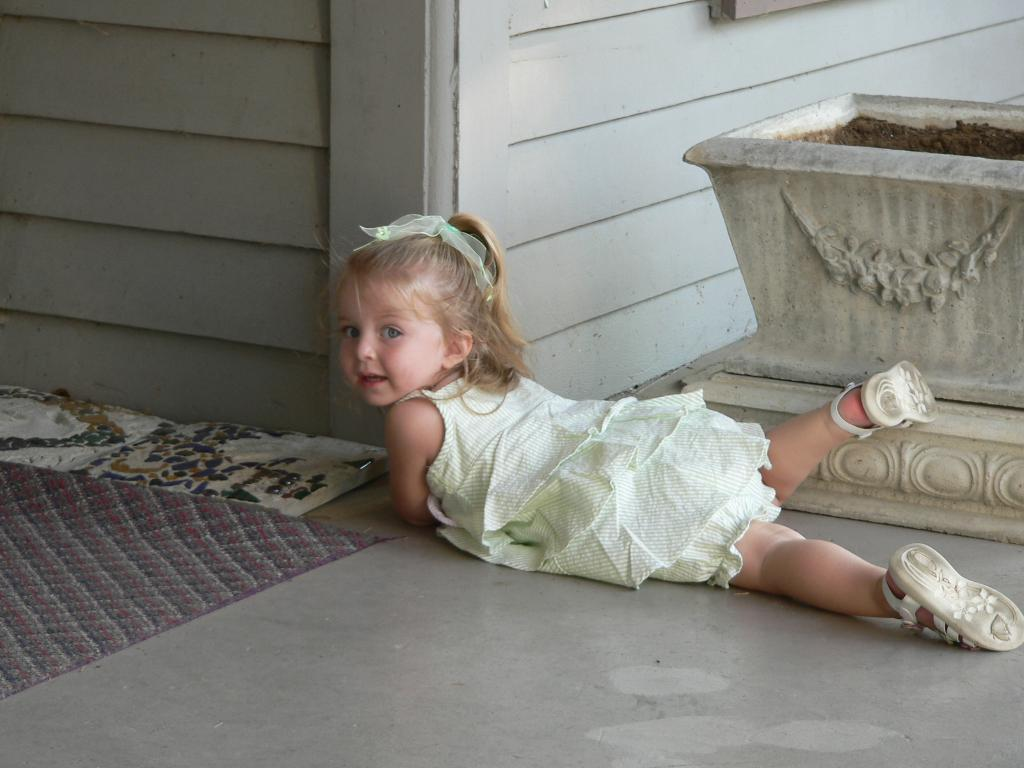What is the girl in the image doing? The girl is lying on the floor in the image. What can be seen in the background of the image? There is a container filled with sand and a building visible in the background. What type of flooring is present in the background? There is a carpet on the ground in the background. What type of bread is being used to process the salt in the image? There is no bread or salt present in the image, and therefore no such process can be observed. 